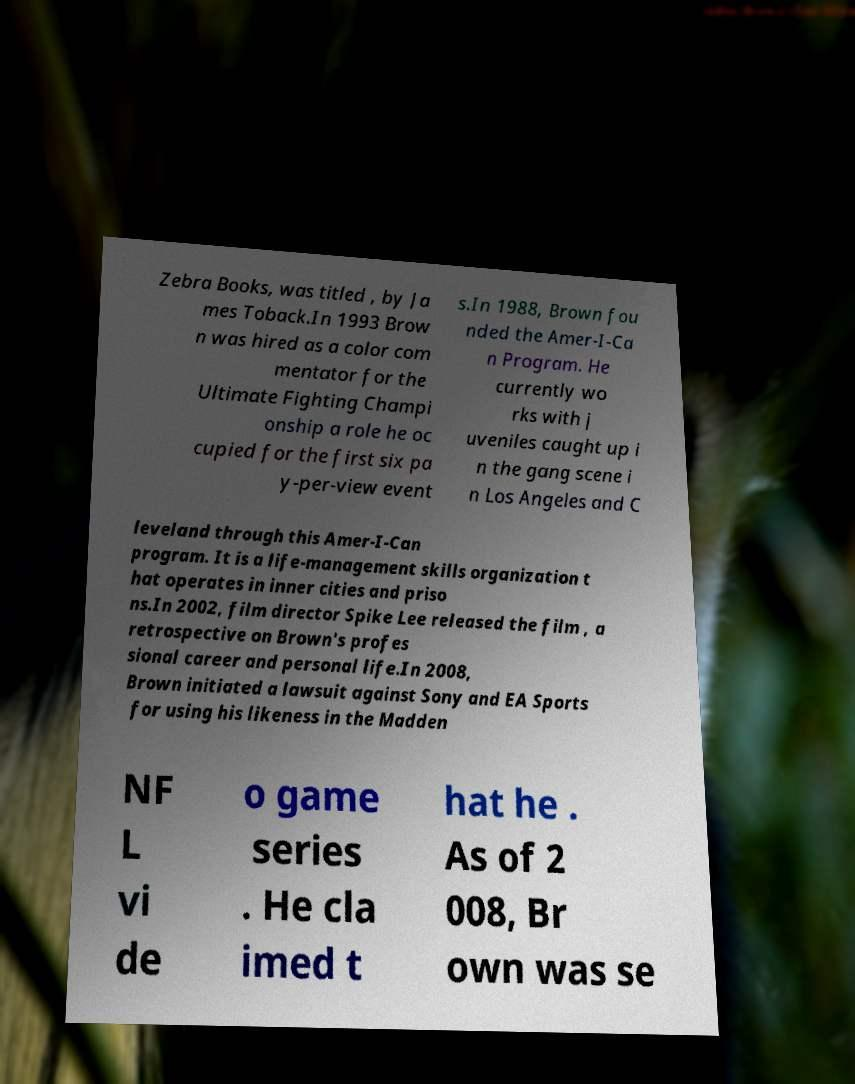Please identify and transcribe the text found in this image. Zebra Books, was titled , by Ja mes Toback.In 1993 Brow n was hired as a color com mentator for the Ultimate Fighting Champi onship a role he oc cupied for the first six pa y-per-view event s.In 1988, Brown fou nded the Amer-I-Ca n Program. He currently wo rks with j uveniles caught up i n the gang scene i n Los Angeles and C leveland through this Amer-I-Can program. It is a life-management skills organization t hat operates in inner cities and priso ns.In 2002, film director Spike Lee released the film , a retrospective on Brown's profes sional career and personal life.In 2008, Brown initiated a lawsuit against Sony and EA Sports for using his likeness in the Madden NF L vi de o game series . He cla imed t hat he . As of 2 008, Br own was se 